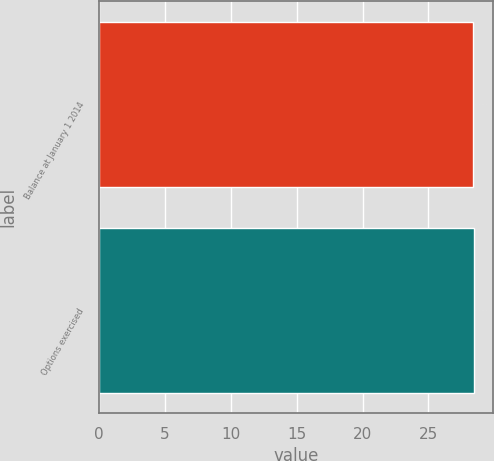Convert chart. <chart><loc_0><loc_0><loc_500><loc_500><bar_chart><fcel>Balance at January 1 2014<fcel>Options exercised<nl><fcel>28.38<fcel>28.48<nl></chart> 